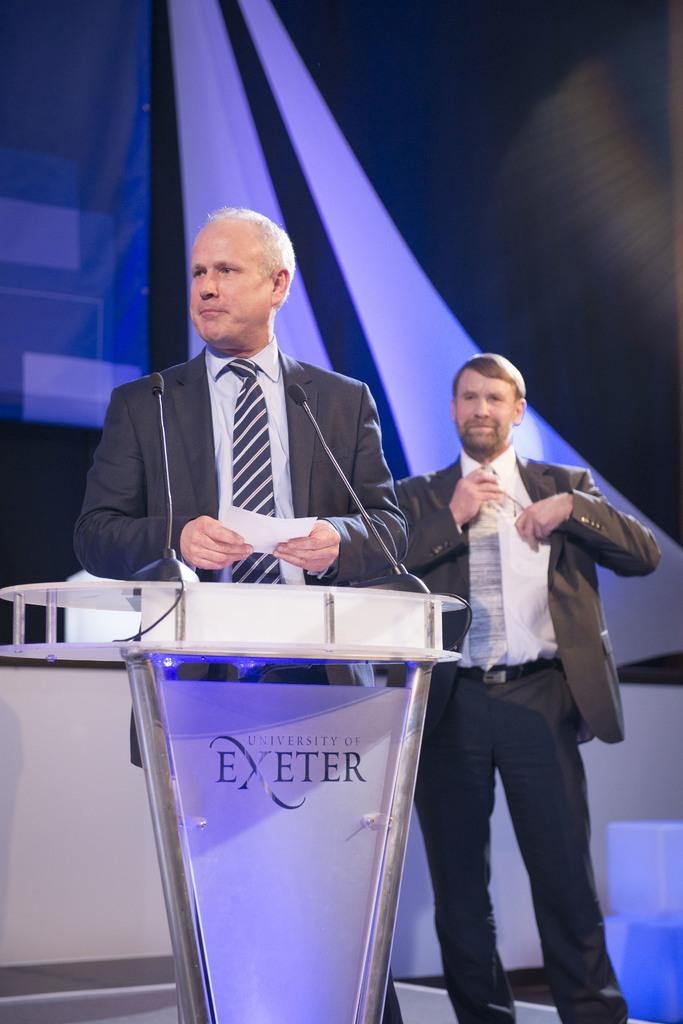<image>
Relay a brief, clear account of the picture shown. A man gives a speech at the University of Exeter. 